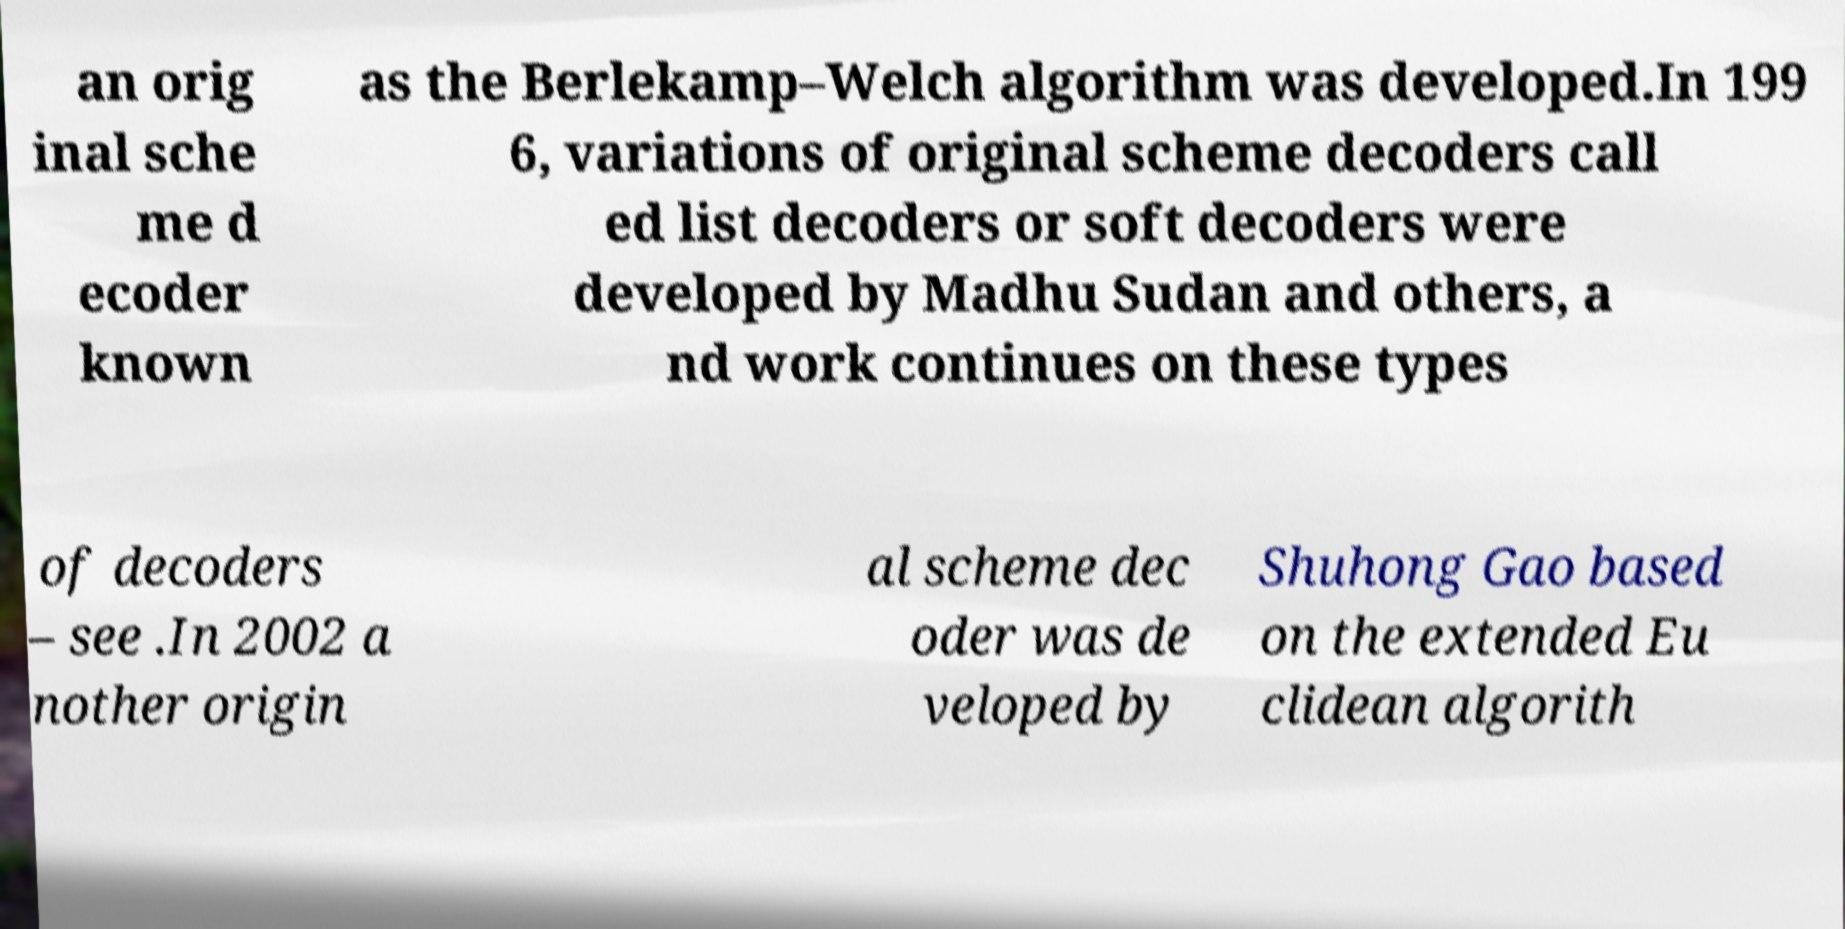Please identify and transcribe the text found in this image. an orig inal sche me d ecoder known as the Berlekamp–Welch algorithm was developed.In 199 6, variations of original scheme decoders call ed list decoders or soft decoders were developed by Madhu Sudan and others, a nd work continues on these types of decoders – see .In 2002 a nother origin al scheme dec oder was de veloped by Shuhong Gao based on the extended Eu clidean algorith 